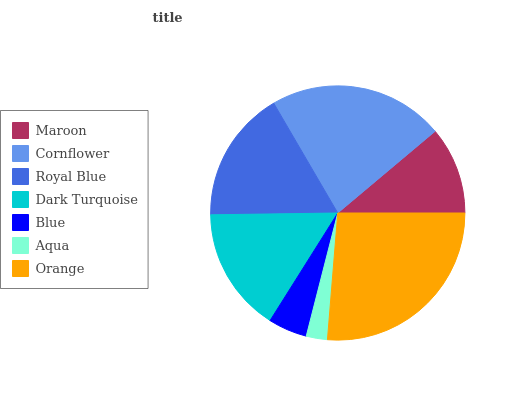Is Aqua the minimum?
Answer yes or no. Yes. Is Orange the maximum?
Answer yes or no. Yes. Is Cornflower the minimum?
Answer yes or no. No. Is Cornflower the maximum?
Answer yes or no. No. Is Cornflower greater than Maroon?
Answer yes or no. Yes. Is Maroon less than Cornflower?
Answer yes or no. Yes. Is Maroon greater than Cornflower?
Answer yes or no. No. Is Cornflower less than Maroon?
Answer yes or no. No. Is Dark Turquoise the high median?
Answer yes or no. Yes. Is Dark Turquoise the low median?
Answer yes or no. Yes. Is Aqua the high median?
Answer yes or no. No. Is Blue the low median?
Answer yes or no. No. 